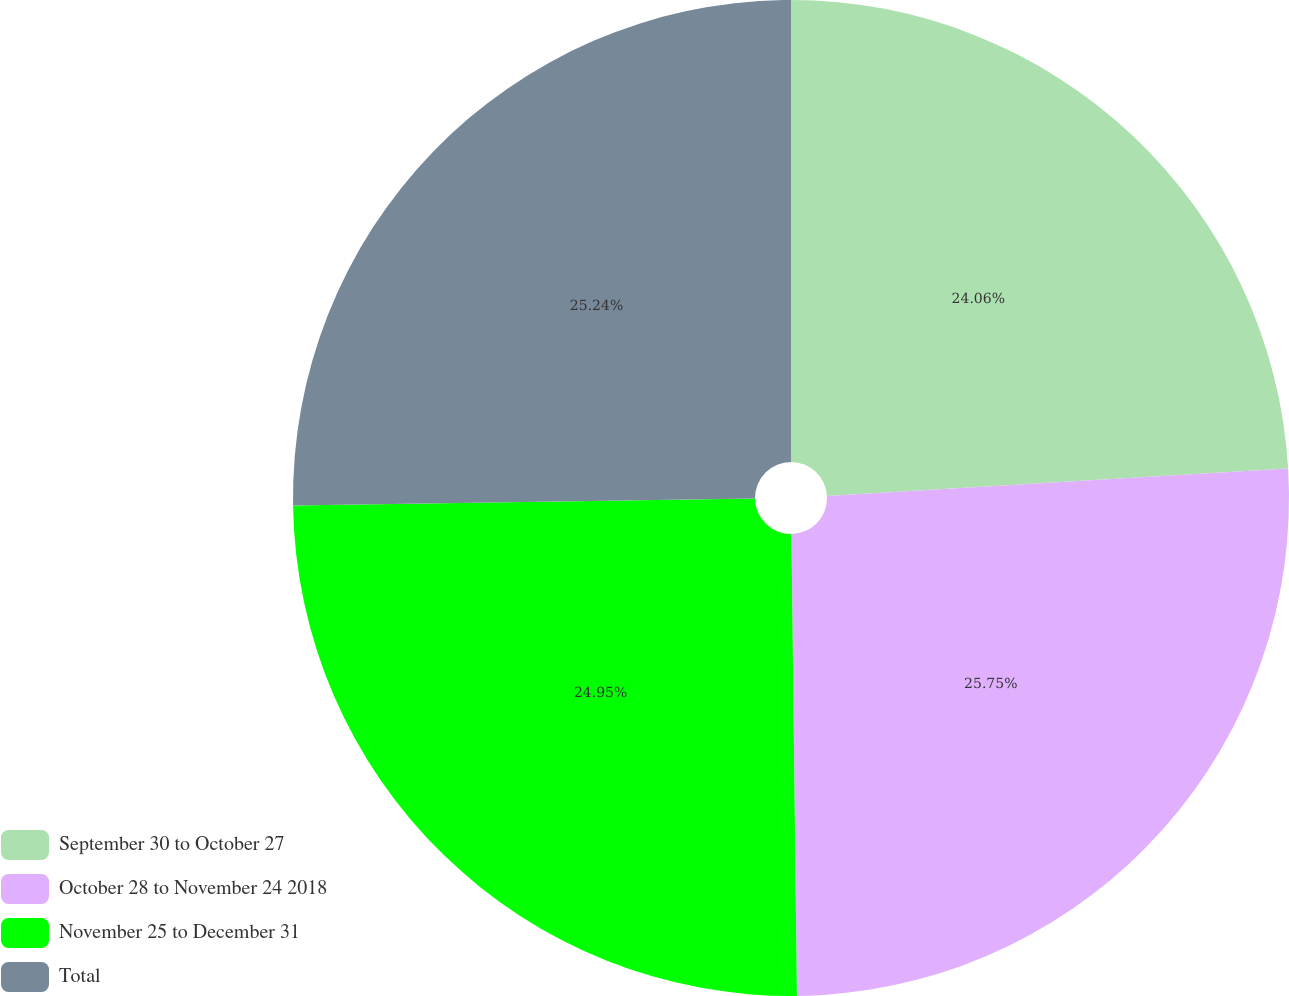<chart> <loc_0><loc_0><loc_500><loc_500><pie_chart><fcel>September 30 to October 27<fcel>October 28 to November 24 2018<fcel>November 25 to December 31<fcel>Total<nl><fcel>24.06%<fcel>25.75%<fcel>24.95%<fcel>25.24%<nl></chart> 